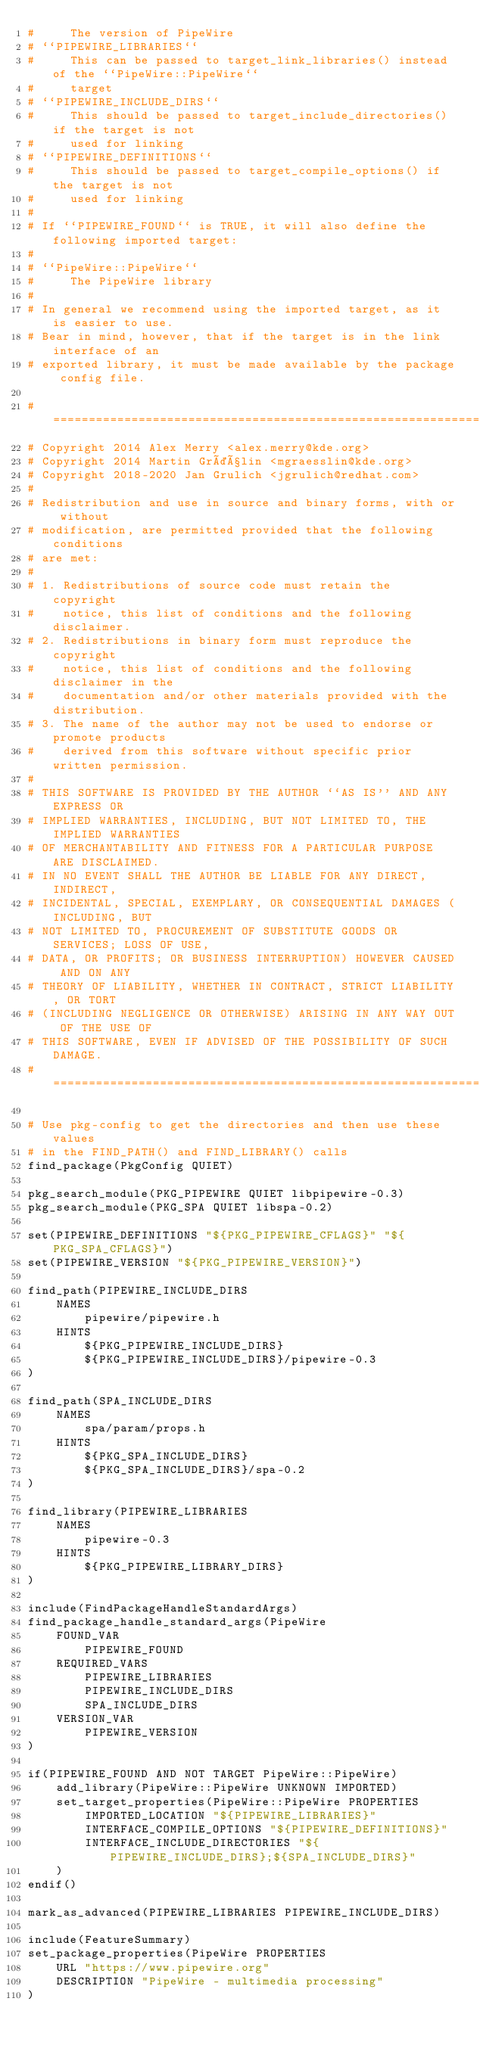Convert code to text. <code><loc_0><loc_0><loc_500><loc_500><_CMake_>#     The version of PipeWire
# ``PIPEWIRE_LIBRARIES``
#     This can be passed to target_link_libraries() instead of the ``PipeWire::PipeWire``
#     target
# ``PIPEWIRE_INCLUDE_DIRS``
#     This should be passed to target_include_directories() if the target is not
#     used for linking
# ``PIPEWIRE_DEFINITIONS``
#     This should be passed to target_compile_options() if the target is not
#     used for linking
#
# If ``PIPEWIRE_FOUND`` is TRUE, it will also define the following imported target:
#
# ``PipeWire::PipeWire``
#     The PipeWire library
#
# In general we recommend using the imported target, as it is easier to use.
# Bear in mind, however, that if the target is in the link interface of an
# exported library, it must be made available by the package config file.

#=============================================================================
# Copyright 2014 Alex Merry <alex.merry@kde.org>
# Copyright 2014 Martin Gräßlin <mgraesslin@kde.org>
# Copyright 2018-2020 Jan Grulich <jgrulich@redhat.com>
#
# Redistribution and use in source and binary forms, with or without
# modification, are permitted provided that the following conditions
# are met:
#
# 1. Redistributions of source code must retain the copyright
#    notice, this list of conditions and the following disclaimer.
# 2. Redistributions in binary form must reproduce the copyright
#    notice, this list of conditions and the following disclaimer in the
#    documentation and/or other materials provided with the distribution.
# 3. The name of the author may not be used to endorse or promote products
#    derived from this software without specific prior written permission.
#
# THIS SOFTWARE IS PROVIDED BY THE AUTHOR ``AS IS'' AND ANY EXPRESS OR
# IMPLIED WARRANTIES, INCLUDING, BUT NOT LIMITED TO, THE IMPLIED WARRANTIES
# OF MERCHANTABILITY AND FITNESS FOR A PARTICULAR PURPOSE ARE DISCLAIMED.
# IN NO EVENT SHALL THE AUTHOR BE LIABLE FOR ANY DIRECT, INDIRECT,
# INCIDENTAL, SPECIAL, EXEMPLARY, OR CONSEQUENTIAL DAMAGES (INCLUDING, BUT
# NOT LIMITED TO, PROCUREMENT OF SUBSTITUTE GOODS OR SERVICES; LOSS OF USE,
# DATA, OR PROFITS; OR BUSINESS INTERRUPTION) HOWEVER CAUSED AND ON ANY
# THEORY OF LIABILITY, WHETHER IN CONTRACT, STRICT LIABILITY, OR TORT
# (INCLUDING NEGLIGENCE OR OTHERWISE) ARISING IN ANY WAY OUT OF THE USE OF
# THIS SOFTWARE, EVEN IF ADVISED OF THE POSSIBILITY OF SUCH DAMAGE.
#=============================================================================

# Use pkg-config to get the directories and then use these values
# in the FIND_PATH() and FIND_LIBRARY() calls
find_package(PkgConfig QUIET)

pkg_search_module(PKG_PIPEWIRE QUIET libpipewire-0.3)
pkg_search_module(PKG_SPA QUIET libspa-0.2)

set(PIPEWIRE_DEFINITIONS "${PKG_PIPEWIRE_CFLAGS}" "${PKG_SPA_CFLAGS}")
set(PIPEWIRE_VERSION "${PKG_PIPEWIRE_VERSION}")

find_path(PIPEWIRE_INCLUDE_DIRS
    NAMES
        pipewire/pipewire.h
    HINTS
        ${PKG_PIPEWIRE_INCLUDE_DIRS}
        ${PKG_PIPEWIRE_INCLUDE_DIRS}/pipewire-0.3
)

find_path(SPA_INCLUDE_DIRS
    NAMES
        spa/param/props.h
    HINTS
        ${PKG_SPA_INCLUDE_DIRS}
        ${PKG_SPA_INCLUDE_DIRS}/spa-0.2
)

find_library(PIPEWIRE_LIBRARIES
    NAMES
        pipewire-0.3
    HINTS
        ${PKG_PIPEWIRE_LIBRARY_DIRS}
)

include(FindPackageHandleStandardArgs)
find_package_handle_standard_args(PipeWire
    FOUND_VAR
        PIPEWIRE_FOUND
    REQUIRED_VARS
        PIPEWIRE_LIBRARIES
        PIPEWIRE_INCLUDE_DIRS
        SPA_INCLUDE_DIRS
    VERSION_VAR
        PIPEWIRE_VERSION
)

if(PIPEWIRE_FOUND AND NOT TARGET PipeWire::PipeWire)
    add_library(PipeWire::PipeWire UNKNOWN IMPORTED)
    set_target_properties(PipeWire::PipeWire PROPERTIES
        IMPORTED_LOCATION "${PIPEWIRE_LIBRARIES}"
        INTERFACE_COMPILE_OPTIONS "${PIPEWIRE_DEFINITIONS}"
        INTERFACE_INCLUDE_DIRECTORIES "${PIPEWIRE_INCLUDE_DIRS};${SPA_INCLUDE_DIRS}"
    )
endif()

mark_as_advanced(PIPEWIRE_LIBRARIES PIPEWIRE_INCLUDE_DIRS)

include(FeatureSummary)
set_package_properties(PipeWire PROPERTIES
    URL "https://www.pipewire.org"
    DESCRIPTION "PipeWire - multimedia processing"
)
</code> 